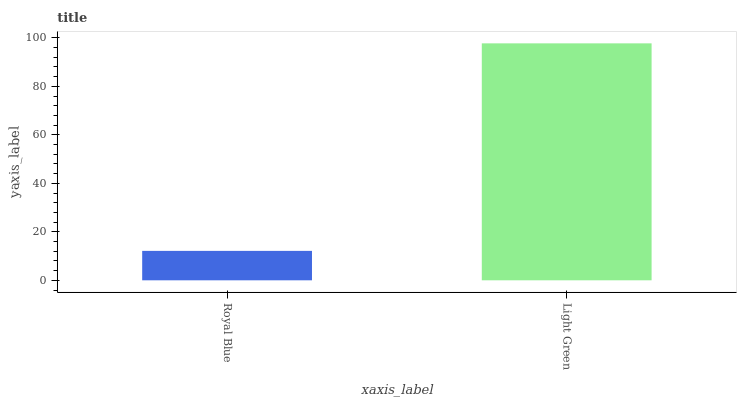Is Royal Blue the minimum?
Answer yes or no. Yes. Is Light Green the maximum?
Answer yes or no. Yes. Is Light Green the minimum?
Answer yes or no. No. Is Light Green greater than Royal Blue?
Answer yes or no. Yes. Is Royal Blue less than Light Green?
Answer yes or no. Yes. Is Royal Blue greater than Light Green?
Answer yes or no. No. Is Light Green less than Royal Blue?
Answer yes or no. No. Is Light Green the high median?
Answer yes or no. Yes. Is Royal Blue the low median?
Answer yes or no. Yes. Is Royal Blue the high median?
Answer yes or no. No. Is Light Green the low median?
Answer yes or no. No. 